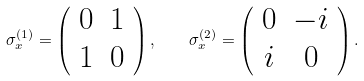<formula> <loc_0><loc_0><loc_500><loc_500>\sigma ^ { ( 1 ) } _ { x } = \left ( \begin{array} { c c } 0 & 1 \\ 1 & 0 \end{array} \right ) , \quad \sigma ^ { ( 2 ) } _ { x } = \left ( \begin{array} { c c } 0 & - i \\ i & 0 \end{array} \right ) .</formula> 